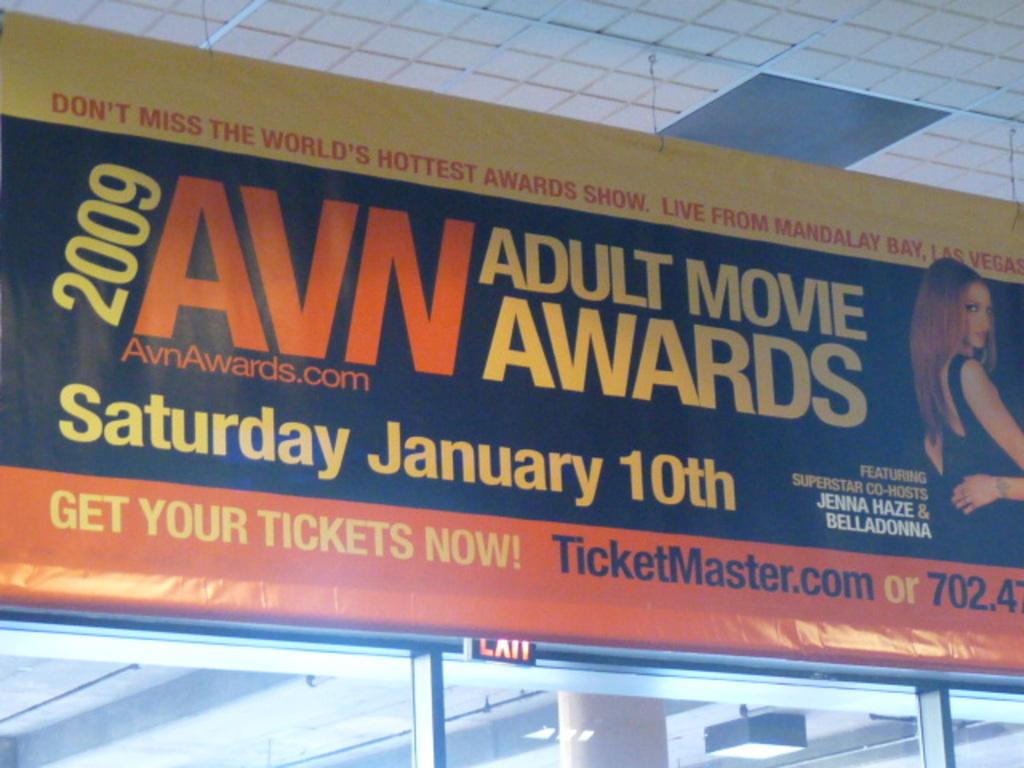What awards is the billboard advertising?
Provide a short and direct response. Adult movie awards. What year is this event?
Make the answer very short. 2009. 